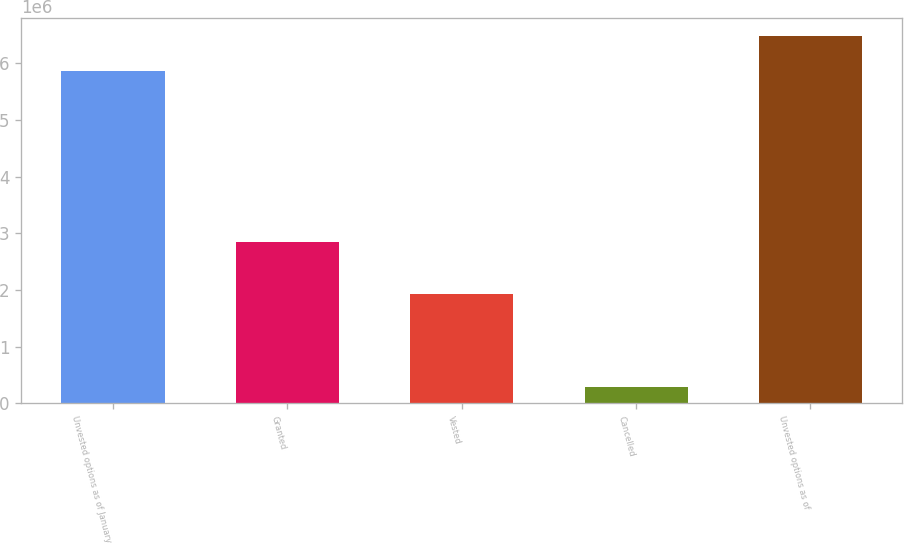Convert chart to OTSL. <chart><loc_0><loc_0><loc_500><loc_500><bar_chart><fcel>Unvested options as of January<fcel>Granted<fcel>Vested<fcel>Cancelled<fcel>Unvested options as of<nl><fcel>5.86483e+06<fcel>2.8455e+06<fcel>1.93701e+06<fcel>288288<fcel>6.48503e+06<nl></chart> 